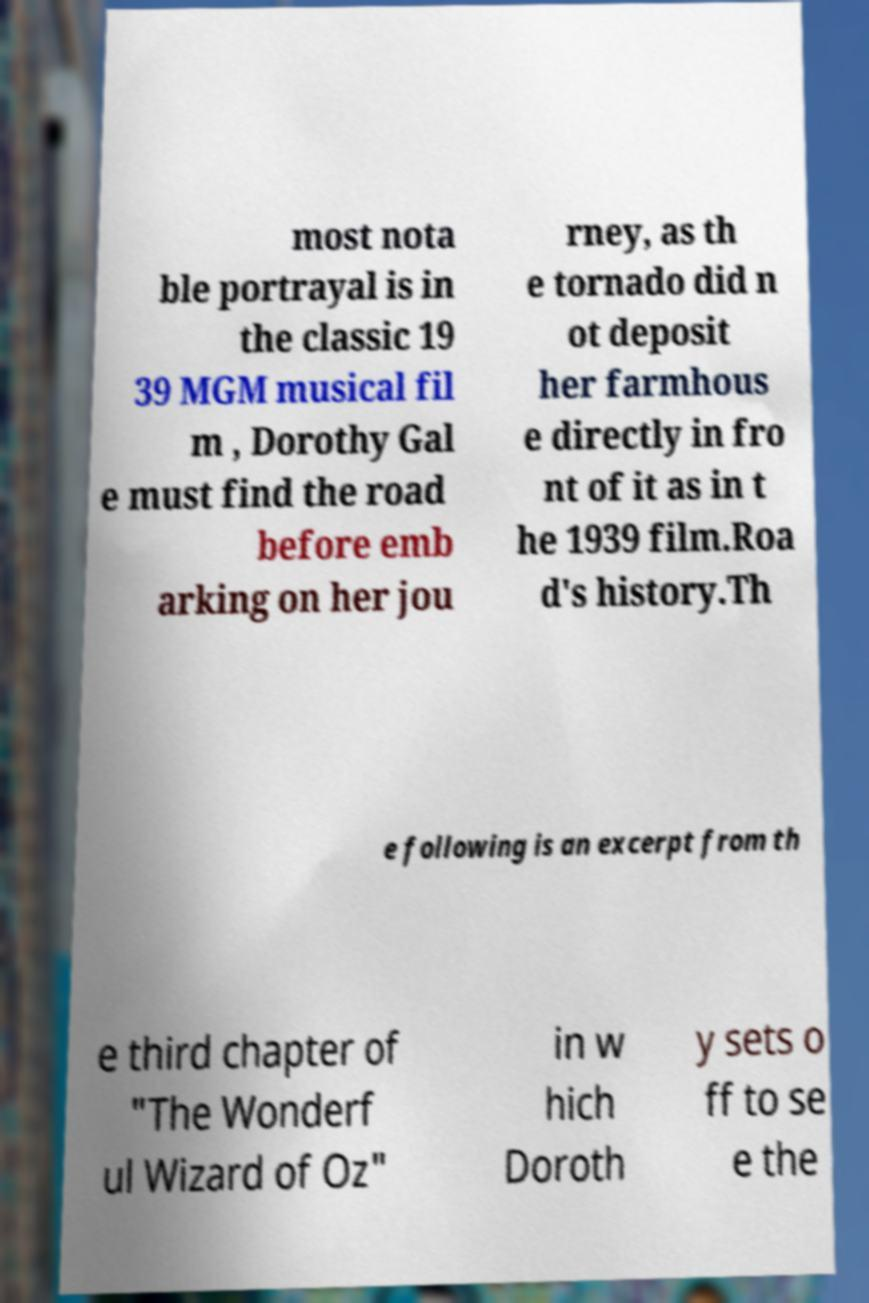What messages or text are displayed in this image? I need them in a readable, typed format. most nota ble portrayal is in the classic 19 39 MGM musical fil m , Dorothy Gal e must find the road before emb arking on her jou rney, as th e tornado did n ot deposit her farmhous e directly in fro nt of it as in t he 1939 film.Roa d's history.Th e following is an excerpt from th e third chapter of "The Wonderf ul Wizard of Oz" in w hich Doroth y sets o ff to se e the 